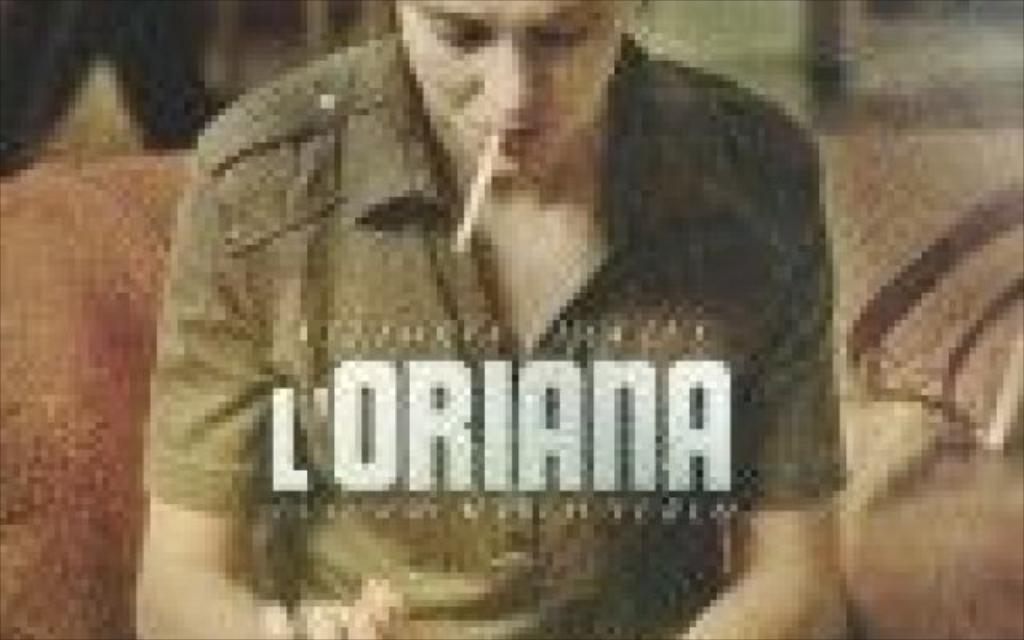Who or what is the main subject in the image? There is a person in the image. What is the person doing in the image? The person has a cigarette in their mouth. Where is the person located in the image? The person is sitting on a sofa. What type of structure can be seen in the background of the image? There is no structure visible in the background of the image. How does the person's cough sound in the image? The image does not provide any auditory information, so it is impossible to determine how the person's cough sounds. 